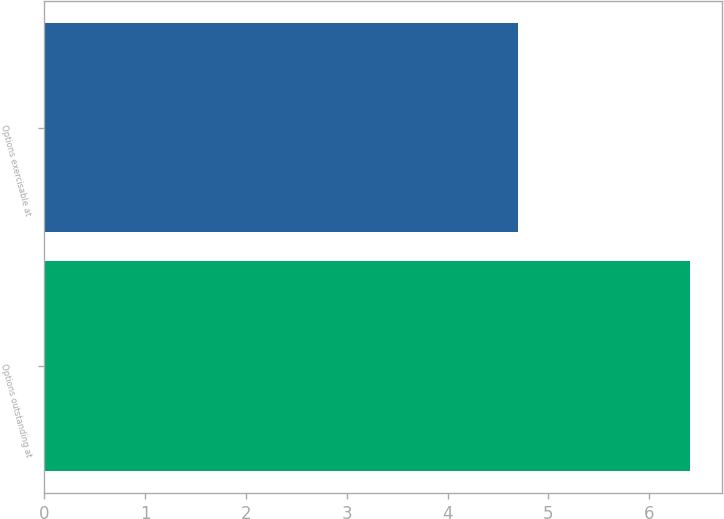<chart> <loc_0><loc_0><loc_500><loc_500><bar_chart><fcel>Options outstanding at<fcel>Options exercisable at<nl><fcel>6.4<fcel>4.7<nl></chart> 